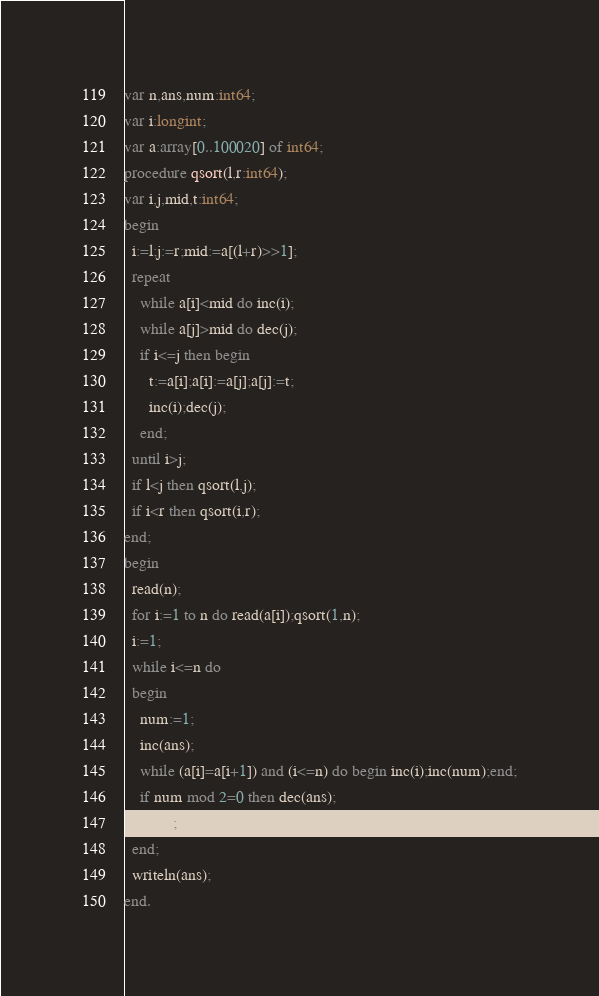Convert code to text. <code><loc_0><loc_0><loc_500><loc_500><_Pascal_>var n,ans,num:int64;
var i:longint;
var a:array[0..100020] of int64;
procedure qsort(l,r:int64);
var i,j,mid,t:int64;
begin
  i:=l;j:=r;mid:=a[(l+r)>>1];
  repeat
    while a[i]<mid do inc(i);
    while a[j]>mid do dec(j);
    if i<=j then begin
      t:=a[i];a[i]:=a[j];a[j]:=t;
      inc(i);dec(j);
    end;
  until i>j;
  if l<j then qsort(l,j);
  if i<r then qsort(i,r);
end;
begin
  read(n);
  for i:=1 to n do read(a[i]);qsort(1,n);
  i:=1;
  while i<=n do
  begin
    num:=1;
    inc(ans);
    while (a[i]=a[i+1]) and (i<=n) do begin inc(i);inc(num);end;
    if num mod 2=0 then dec(ans);
    inc(i);
  end;
  writeln(ans);
end.</code> 